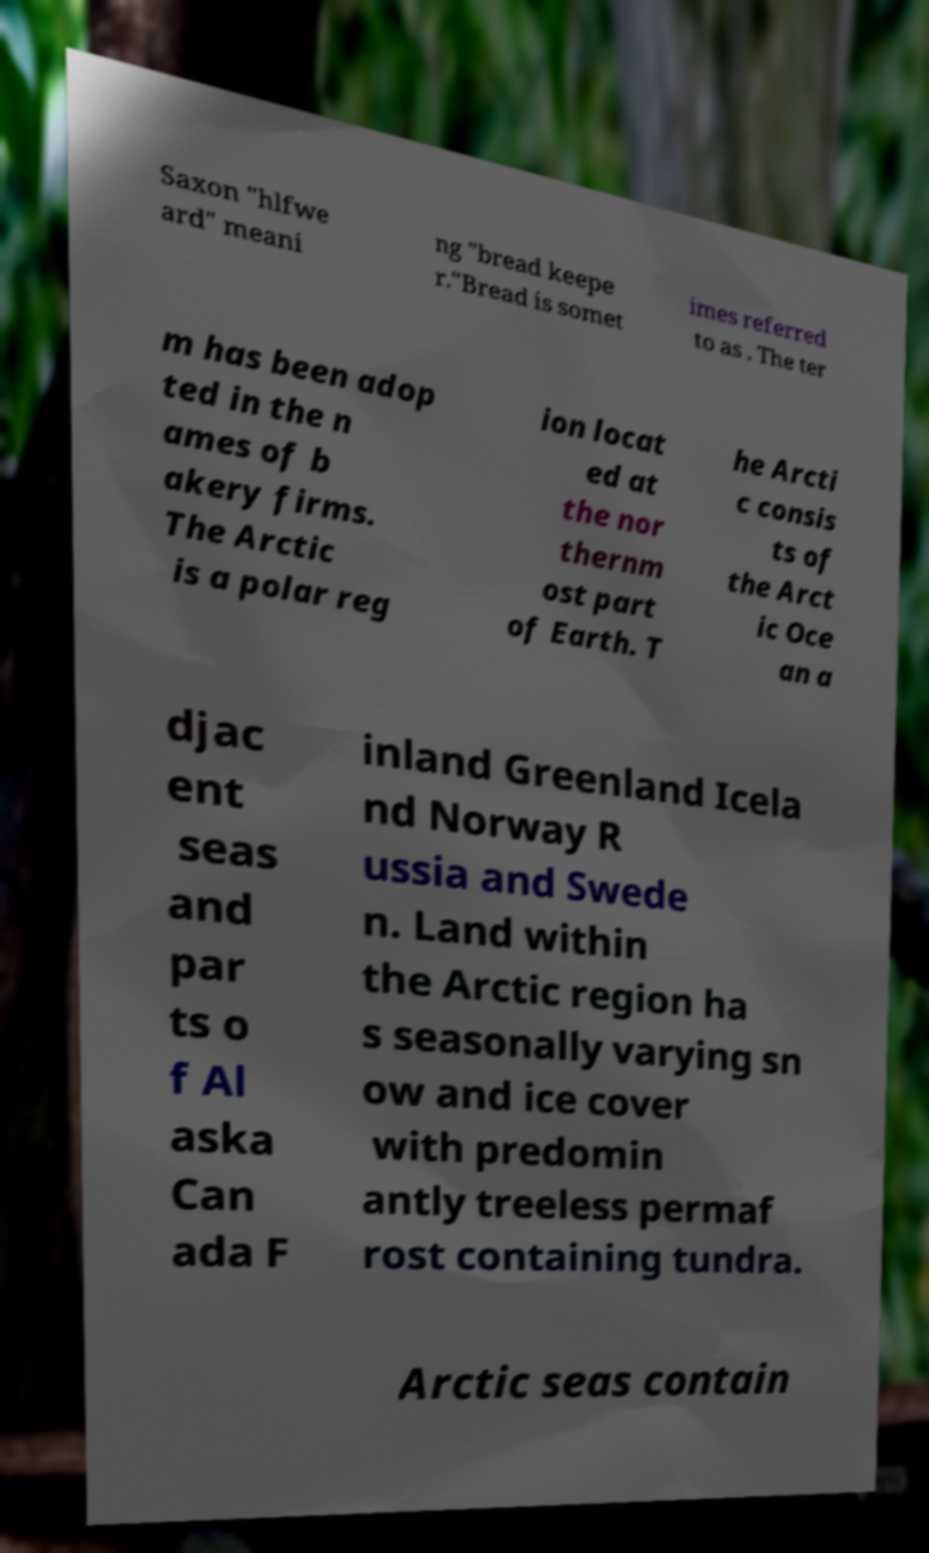Please identify and transcribe the text found in this image. Saxon "hlfwe ard" meani ng "bread keepe r."Bread is somet imes referred to as . The ter m has been adop ted in the n ames of b akery firms. The Arctic is a polar reg ion locat ed at the nor thernm ost part of Earth. T he Arcti c consis ts of the Arct ic Oce an a djac ent seas and par ts o f Al aska Can ada F inland Greenland Icela nd Norway R ussia and Swede n. Land within the Arctic region ha s seasonally varying sn ow and ice cover with predomin antly treeless permaf rost containing tundra. Arctic seas contain 